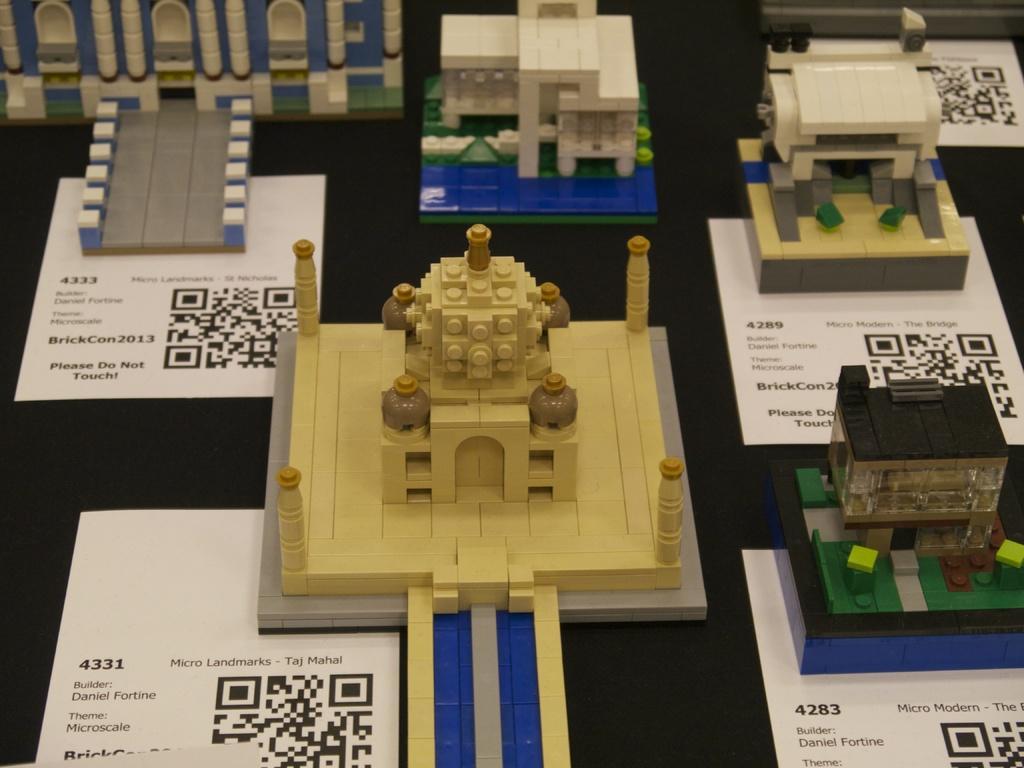Could you give a brief overview of what you see in this image? In this image I can see few miniatures, they are in brown and cream color, and the floor is in black color. 